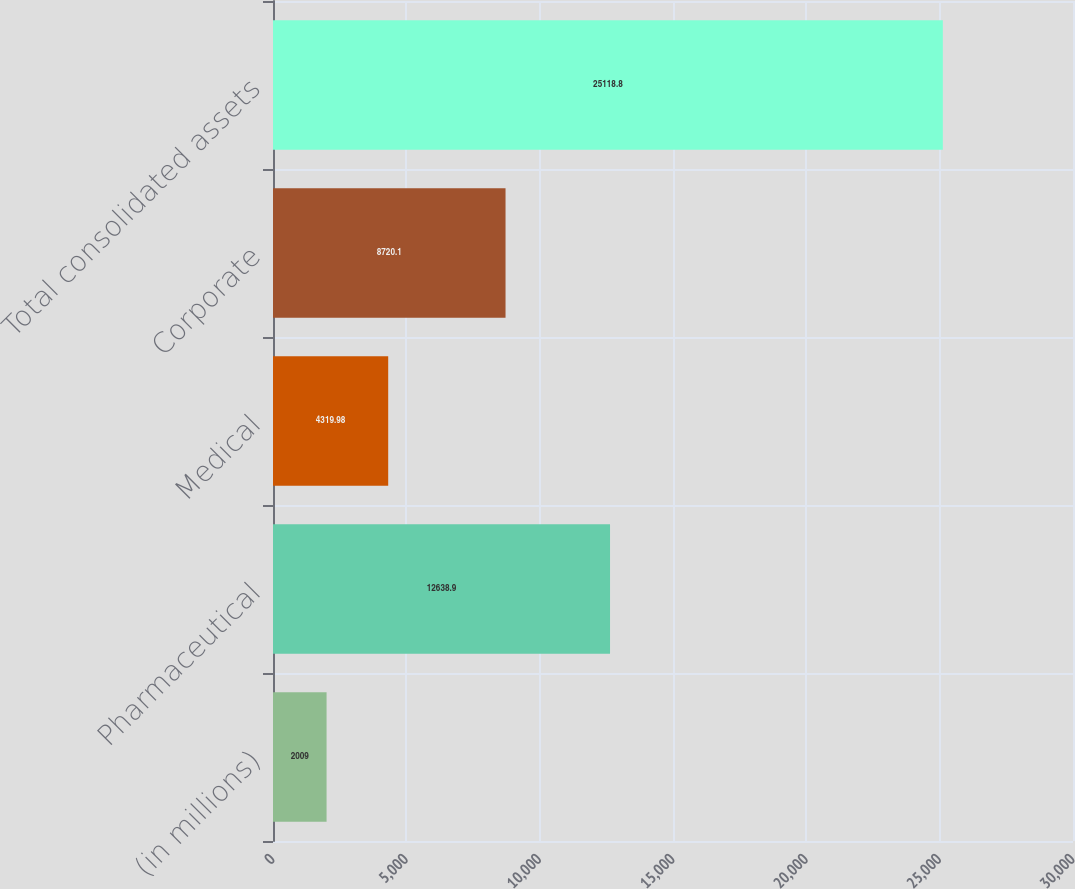<chart> <loc_0><loc_0><loc_500><loc_500><bar_chart><fcel>(in millions)<fcel>Pharmaceutical<fcel>Medical<fcel>Corporate<fcel>Total consolidated assets<nl><fcel>2009<fcel>12638.9<fcel>4319.98<fcel>8720.1<fcel>25118.8<nl></chart> 